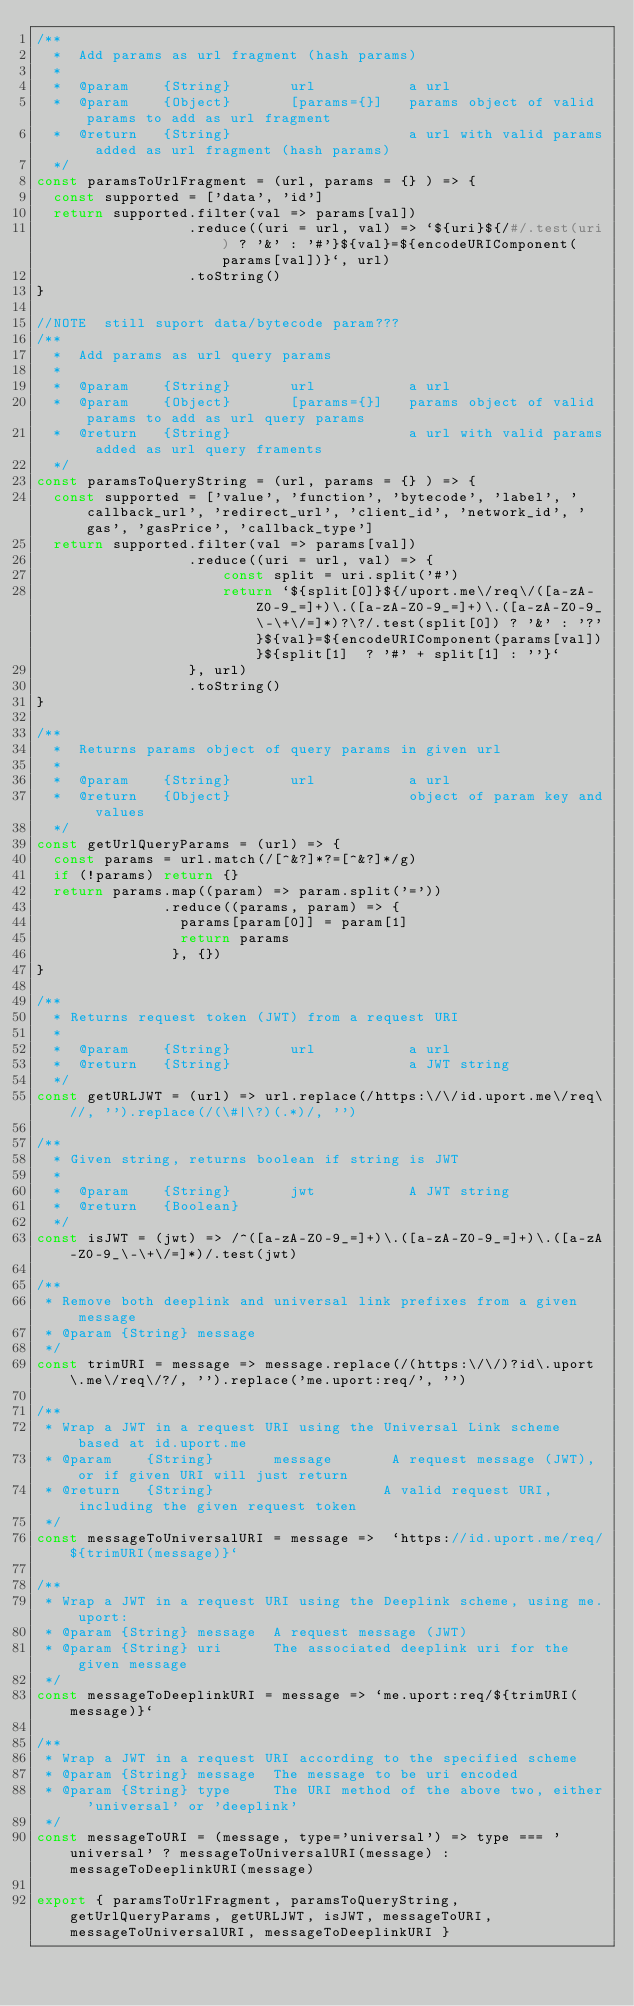<code> <loc_0><loc_0><loc_500><loc_500><_JavaScript_>/**
  *  Add params as url fragment (hash params)
  *
  *  @param    {String}       url           a url
  *  @param    {Object}       [params={}]   params object of valid params to add as url fragment
  *  @return   {String}                     a url with valid params added as url fragment (hash params)
  */
const paramsToUrlFragment = (url, params = {} ) => {
  const supported = ['data', 'id']
  return supported.filter(val => params[val])
                  .reduce((uri = url, val) => `${uri}${/#/.test(uri) ? '&' : '#'}${val}=${encodeURIComponent(params[val])}`, url)
                  .toString()
}

//NOTE  still suport data/bytecode param???
/**
  *  Add params as url query params
  *
  *  @param    {String}       url           a url
  *  @param    {Object}       [params={}]   params object of valid params to add as url query params
  *  @return   {String}                     a url with valid params added as url query framents
  */
const paramsToQueryString = (url, params = {} ) => {
  const supported = ['value', 'function', 'bytecode', 'label', 'callback_url', 'redirect_url', 'client_id', 'network_id', 'gas', 'gasPrice', 'callback_type']
  return supported.filter(val => params[val])
                  .reduce((uri = url, val) => {
                      const split = uri.split('#')
                      return `${split[0]}${/uport.me\/req\/([a-zA-Z0-9_=]+)\.([a-zA-Z0-9_=]+)\.([a-zA-Z0-9_\-\+\/=]*)?\?/.test(split[0]) ? '&' : '?'}${val}=${encodeURIComponent(params[val])}${split[1]  ? '#' + split[1] : ''}`
                  }, url)
                  .toString()
}

/**
  *  Returns params object of query params in given url
  *
  *  @param    {String}       url           a url
  *  @return   {Object}                     object of param key and values
  */
const getUrlQueryParams = (url) => {
  const params = url.match(/[^&?]*?=[^&?]*/g)
  if (!params) return {}
  return params.map((param) => param.split('='))
               .reduce((params, param) => {
                 params[param[0]] = param[1]
                 return params
                }, {})
}

/**
  * Returns request token (JWT) from a request URI
  *
  *  @param    {String}       url           a url
  *  @return   {String}                     a JWT string
  */
const getURLJWT = (url) => url.replace(/https:\/\/id.uport.me\/req\//, '').replace(/(\#|\?)(.*)/, '')

/**
  * Given string, returns boolean if string is JWT
  *
  *  @param    {String}       jwt           A JWT string
  *  @return   {Boolean}
  */
const isJWT = (jwt) => /^([a-zA-Z0-9_=]+)\.([a-zA-Z0-9_=]+)\.([a-zA-Z0-9_\-\+\/=]*)/.test(jwt)

/**
 * Remove both deeplink and universal link prefixes from a given message
 * @param {String} message 
 */
const trimURI = message => message.replace(/(https:\/\/)?id\.uport\.me\/req\/?/, '').replace('me.uport:req/', '')

/**
 * Wrap a JWT in a request URI using the Universal Link scheme based at id.uport.me
 * @param    {String}       message       A request message (JWT), or if given URI will just return
 * @return   {String}                    A valid request URI, including the given request token
 */
const messageToUniversalURI = message =>  `https://id.uport.me/req/${trimURI(message)}`

/**
 * Wrap a JWT in a request URI using the Deeplink scheme, using me.uport: 
 * @param {String} message  A request message (JWT)
 * @param {String} uri      The associated deeplink uri for the given message
 */
const messageToDeeplinkURI = message => `me.uport:req/${trimURI(message)}`

/**
 * Wrap a JWT in a request URI according to the specified scheme
 * @param {String} message  The message to be uri encoded
 * @param {String} type     The URI method of the above two, either 'universal' or 'deeplink'
 */
const messageToURI = (message, type='universal') => type === 'universal' ? messageToUniversalURI(message) : messageToDeeplinkURI(message)

export { paramsToUrlFragment, paramsToQueryString, getUrlQueryParams, getURLJWT, isJWT, messageToURI, messageToUniversalURI, messageToDeeplinkURI }
</code> 